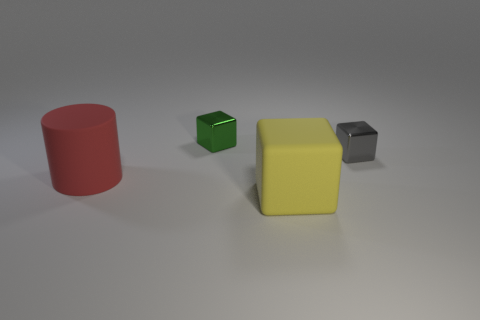Add 3 blocks. How many objects exist? 7 Subtract all cylinders. How many objects are left? 3 Add 4 big red objects. How many big red objects are left? 5 Add 2 large cubes. How many large cubes exist? 3 Subtract 0 cyan blocks. How many objects are left? 4 Subtract all yellow cubes. Subtract all green blocks. How many objects are left? 2 